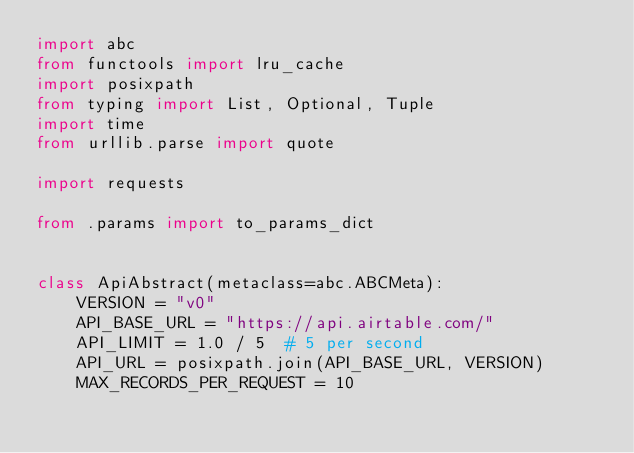<code> <loc_0><loc_0><loc_500><loc_500><_Python_>import abc
from functools import lru_cache
import posixpath
from typing import List, Optional, Tuple
import time
from urllib.parse import quote

import requests

from .params import to_params_dict


class ApiAbstract(metaclass=abc.ABCMeta):
    VERSION = "v0"
    API_BASE_URL = "https://api.airtable.com/"
    API_LIMIT = 1.0 / 5  # 5 per second
    API_URL = posixpath.join(API_BASE_URL, VERSION)
    MAX_RECORDS_PER_REQUEST = 10
</code> 